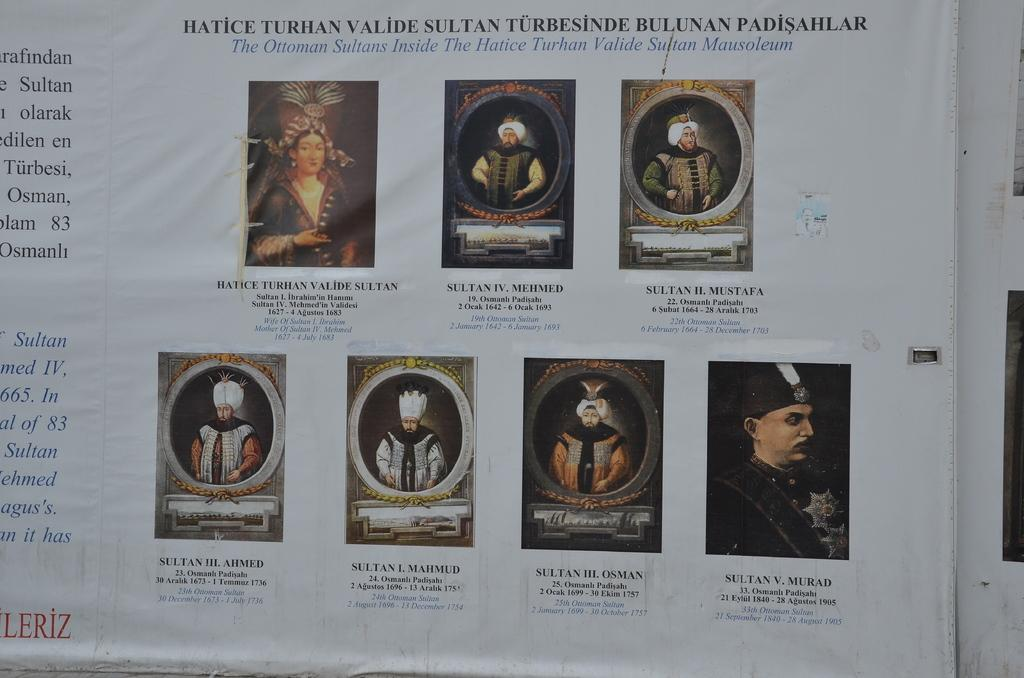What is the main object in the center of the image? There is a board in the center of the image. What is happening on the board? There are persons on the board. What can be seen written on the board? There is text on the board. Can you tell me how many zebras are standing next to the board in the image? There are no zebras present in the image. What type of clothing is the fireman wearing in the image? There is no fireman or any clothing mentioned in the image; it only features a board with persons and text. 